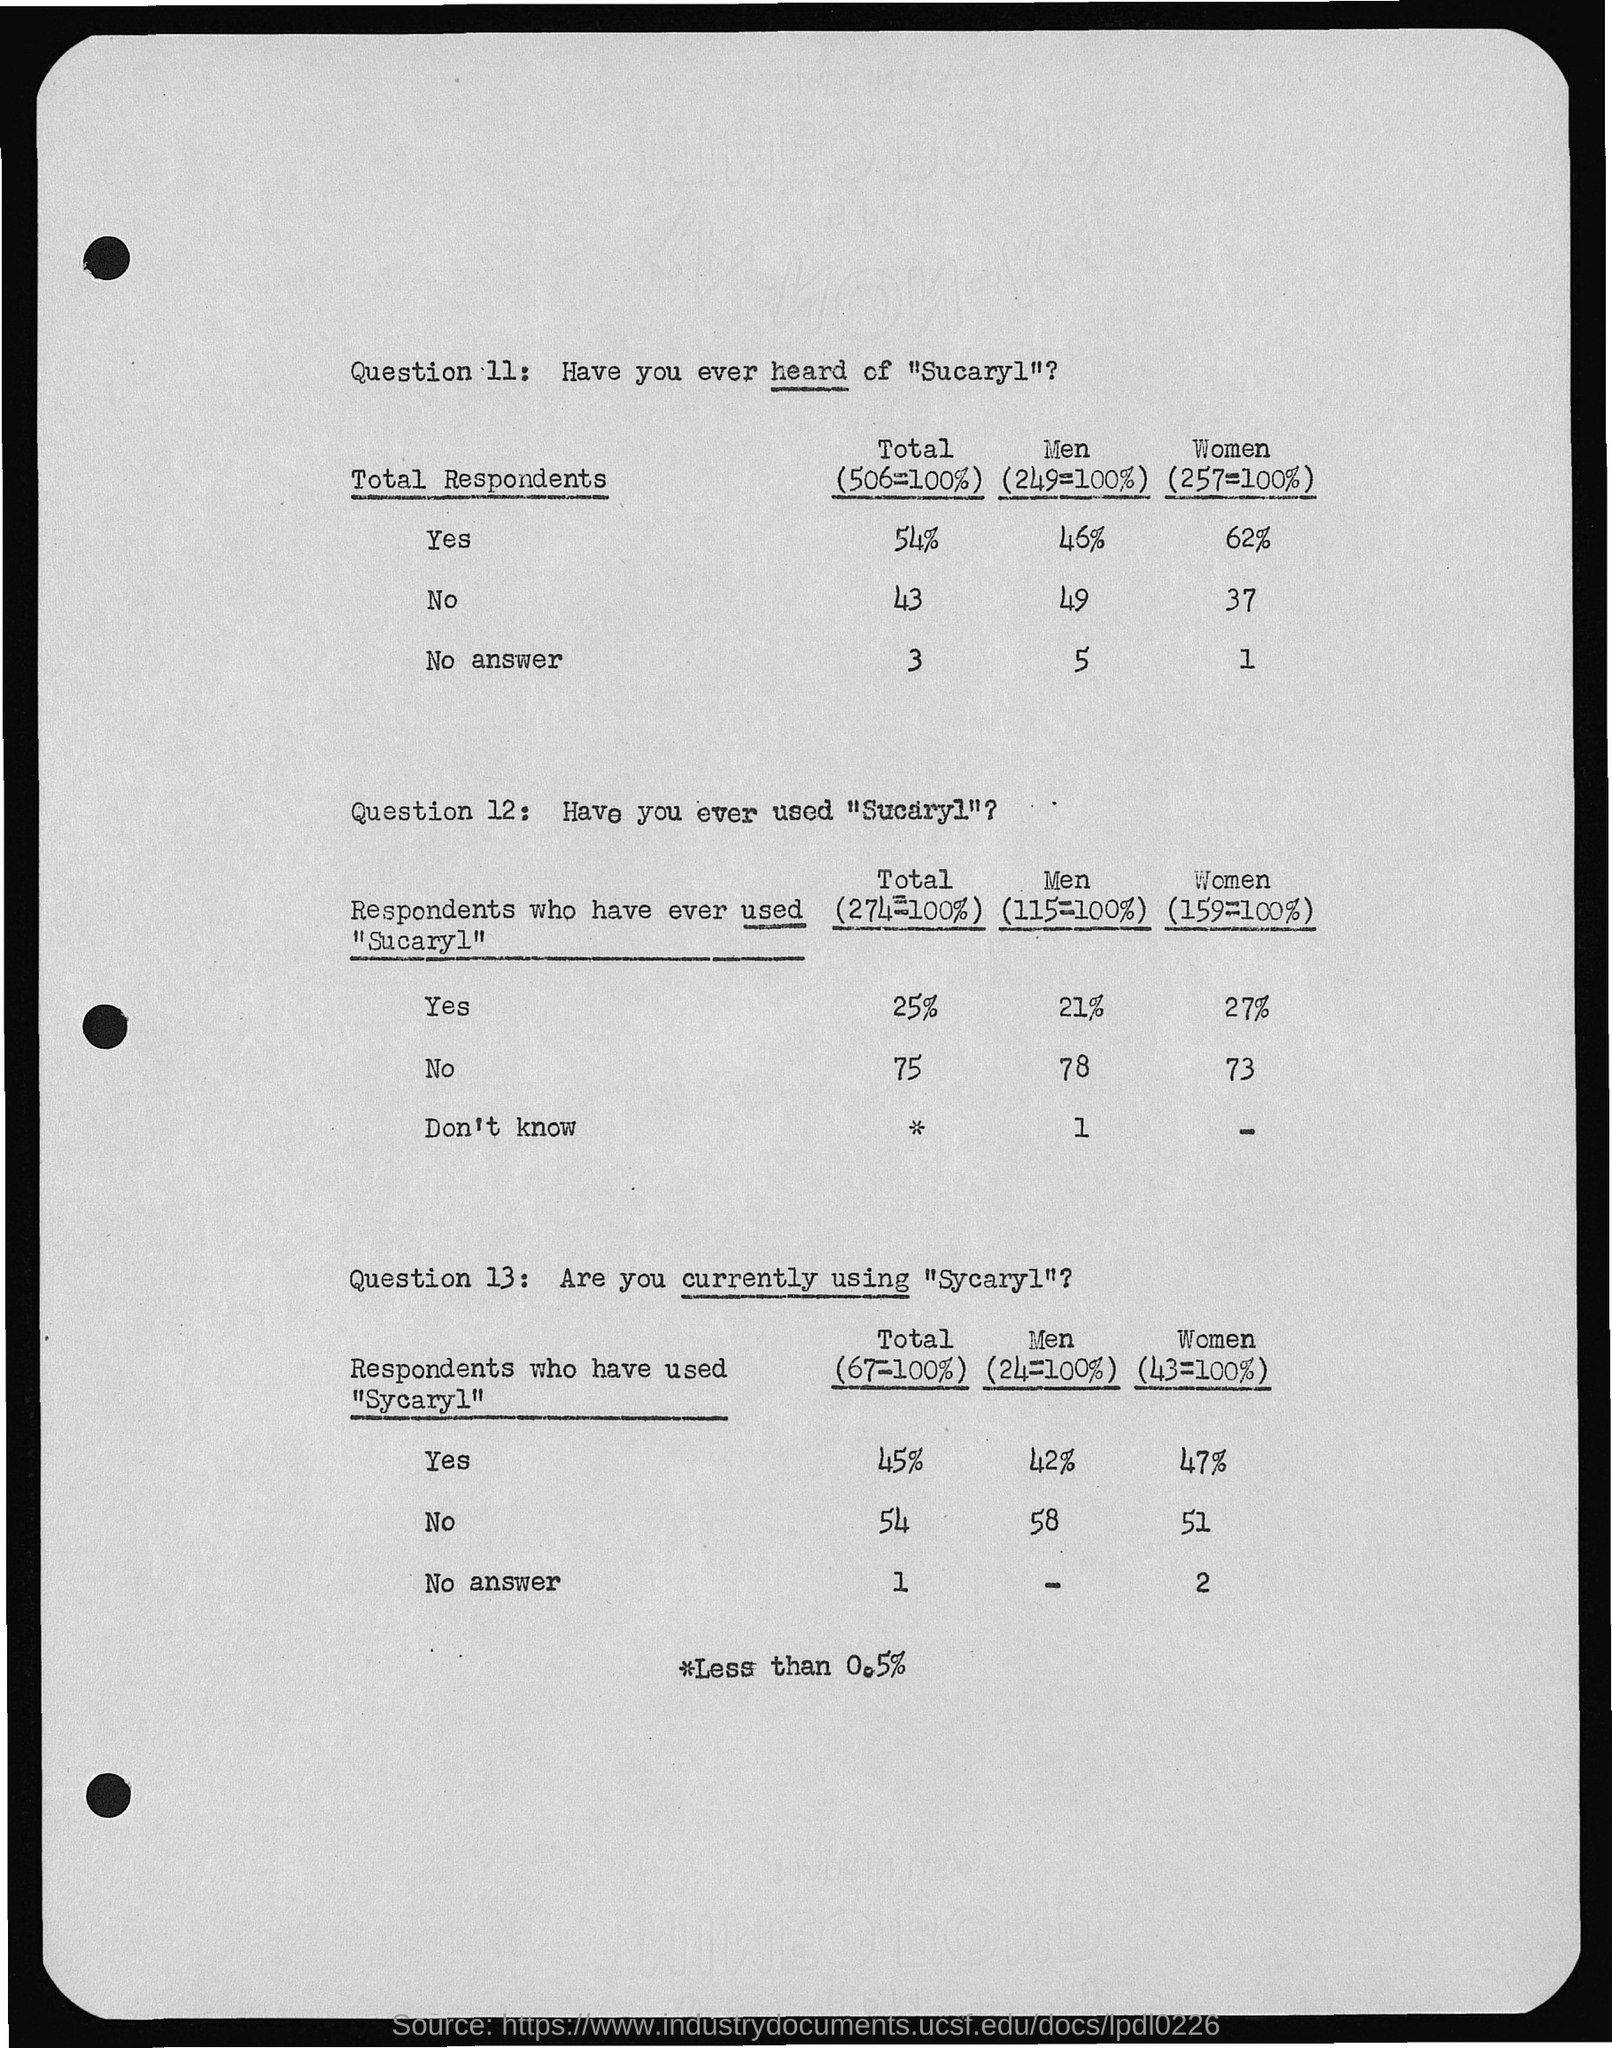Point out several critical features in this image. Thirty-seven women who have heard of Sucaryl said yes. Of the 73 women who have used Sucaryl, 73 said no. Of the 21 men who have used Sucaryl and responded with 'yes', 21 have said yes. Out of the women who have heard of Sucaryl and responded with 'yes', 62 of them said yes. Out of the total number of respondents who have heard of Sucaryl and answered no, 43 answered in the negative. 